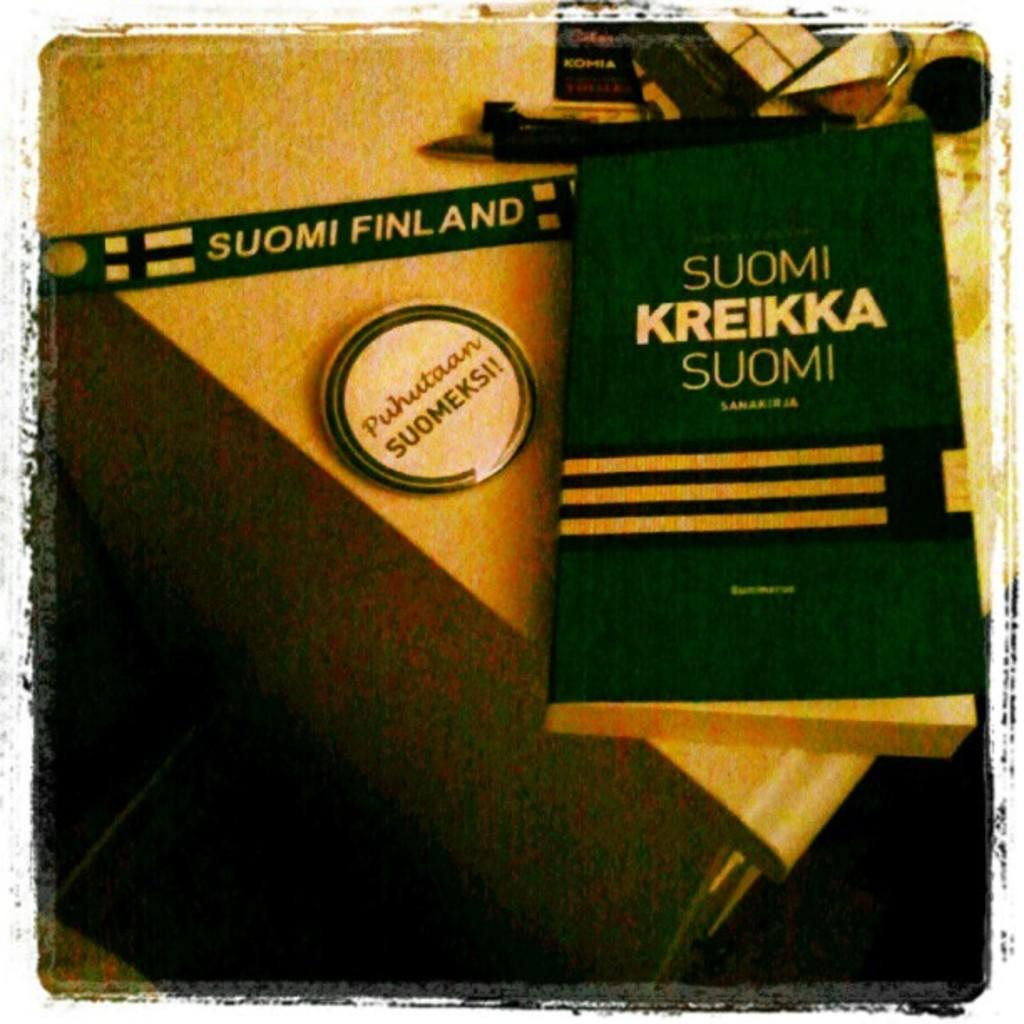<image>
Summarize the visual content of the image. A counter top has a green book that says Suomi Kreikka Suomi on it. 